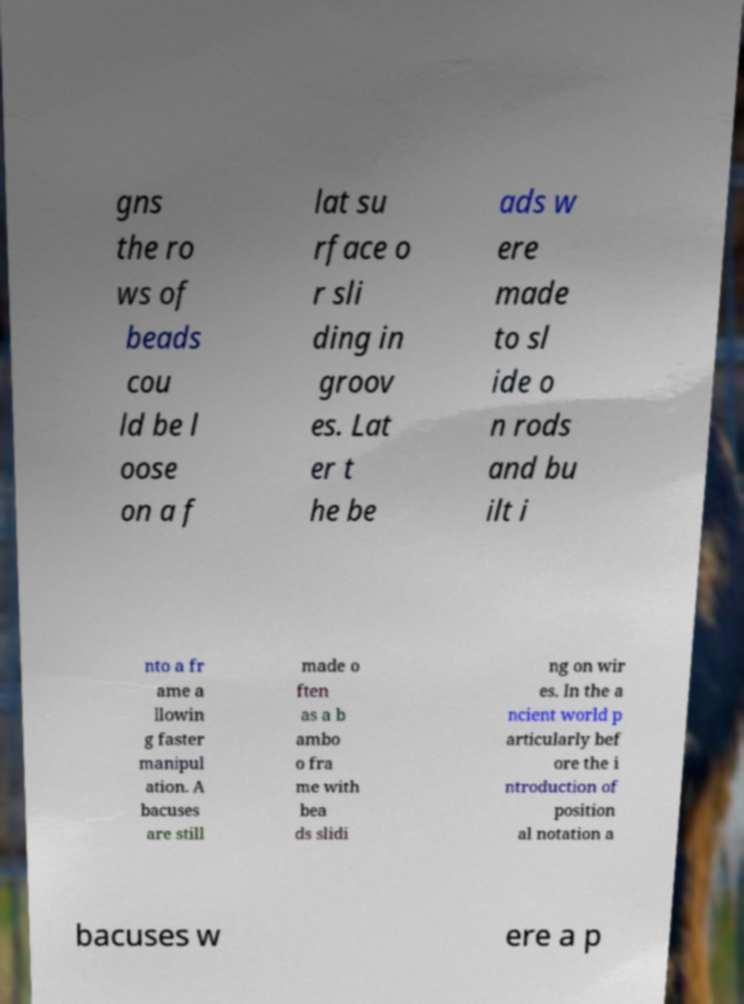Please read and relay the text visible in this image. What does it say? gns the ro ws of beads cou ld be l oose on a f lat su rface o r sli ding in groov es. Lat er t he be ads w ere made to sl ide o n rods and bu ilt i nto a fr ame a llowin g faster manipul ation. A bacuses are still made o ften as a b ambo o fra me with bea ds slidi ng on wir es. In the a ncient world p articularly bef ore the i ntroduction of position al notation a bacuses w ere a p 